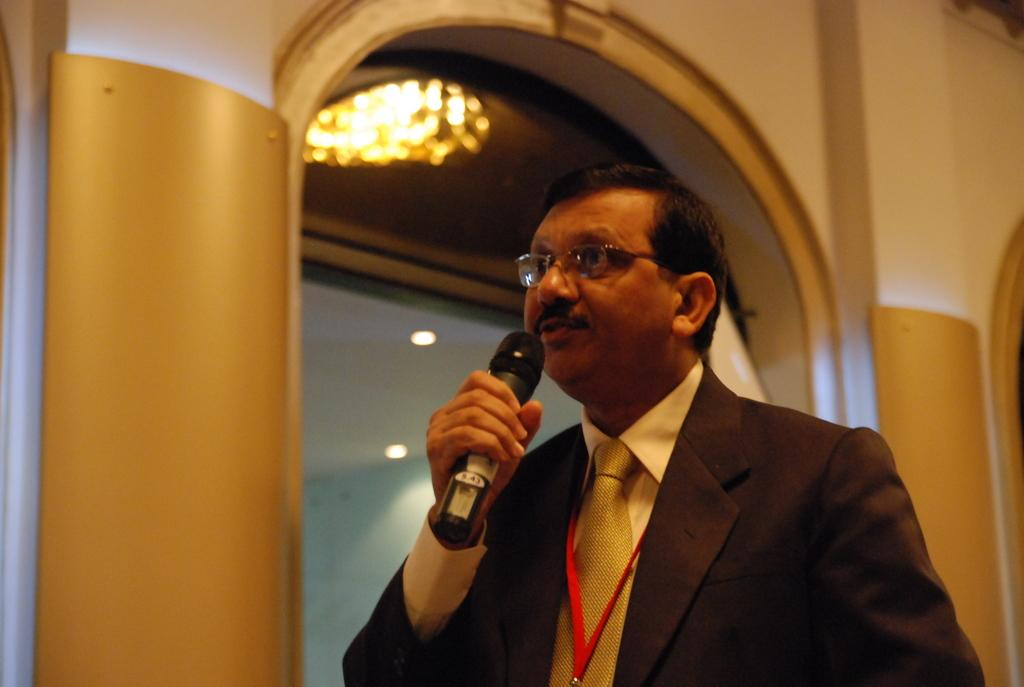What is the person in the image holding? The person is holding a microphone. What color is the coat the person is wearing? The person is wearing a brown coat. What color is the shirt the person is wearing? The person is wearing a light yellow shirt. What type of accessory is the person wearing around their neck? The person is wearing a yellow tie. What type of identification is the person wearing? The person is wearing a red tag. What type of eyewear is the person wearing? The person is wearing glasses (specks). What can be seen in the background of the image? There are buildings visible in the background, and there is light in the background. How many giants are attacking the person in the image? There are no giants present in the image, nor is there any indication of an attack. 